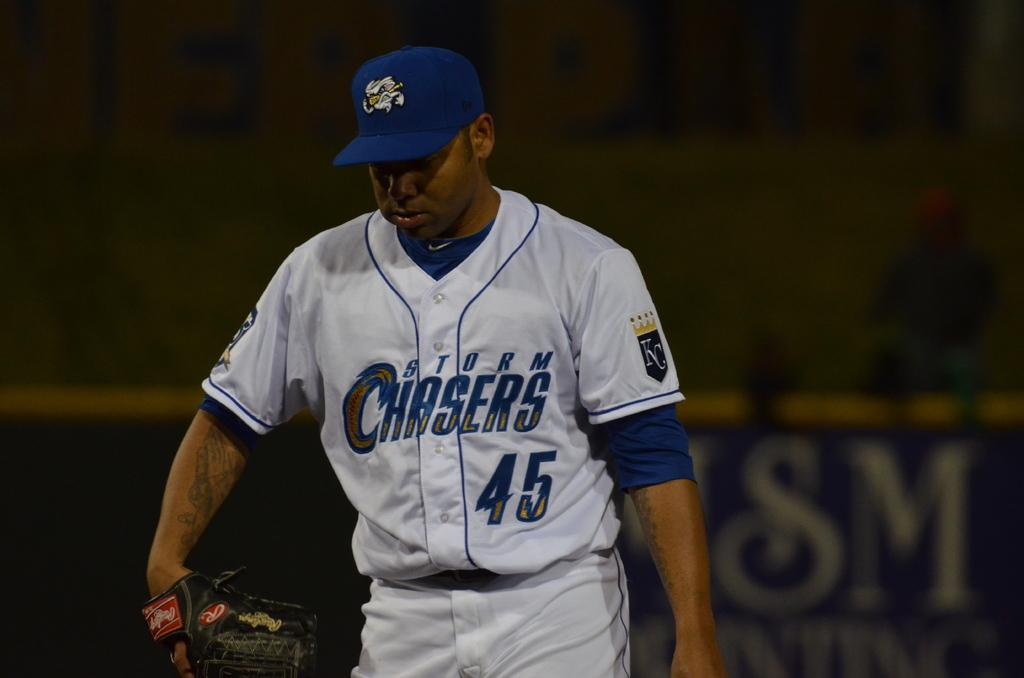<image>
Give a short and clear explanation of the subsequent image. A baseball player is wearing a white uniform with "Storm Chasers 45" on it. 